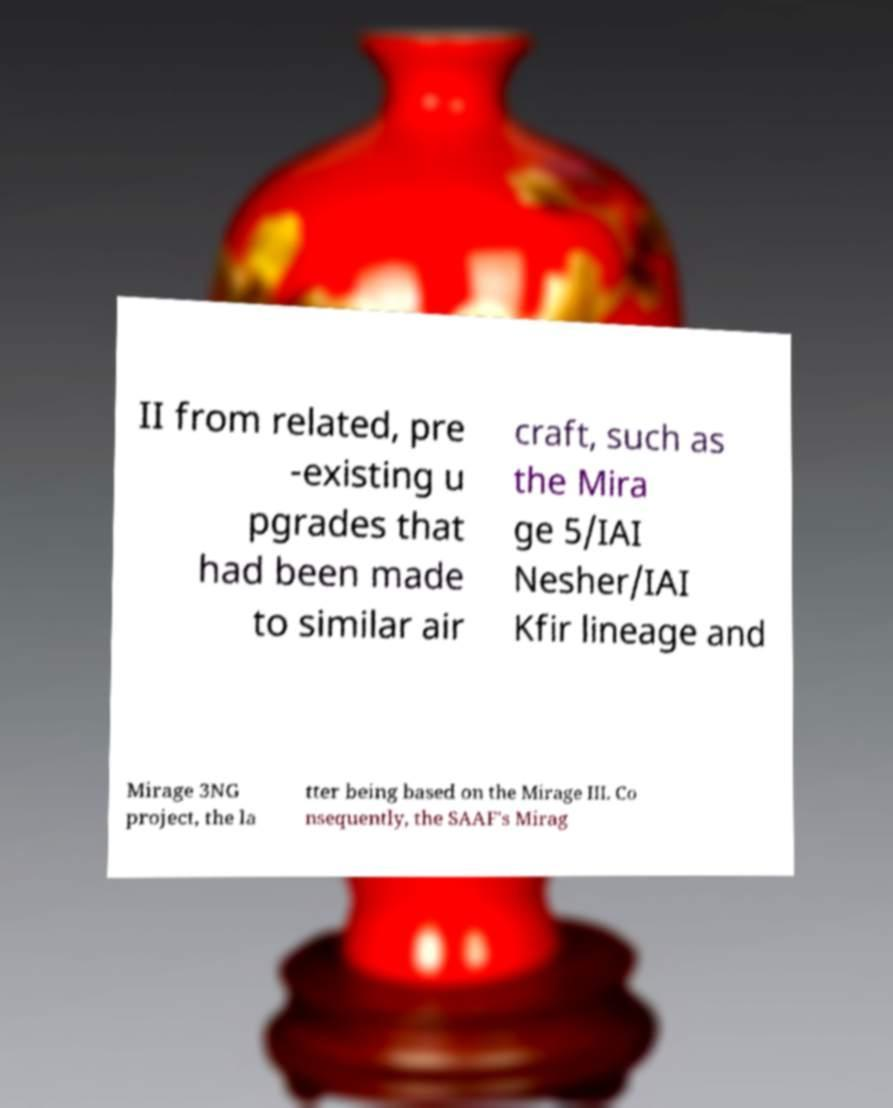I need the written content from this picture converted into text. Can you do that? II from related, pre -existing u pgrades that had been made to similar air craft, such as the Mira ge 5/IAI Nesher/IAI Kfir lineage and Mirage 3NG project, the la tter being based on the Mirage III. Co nsequently, the SAAF's Mirag 